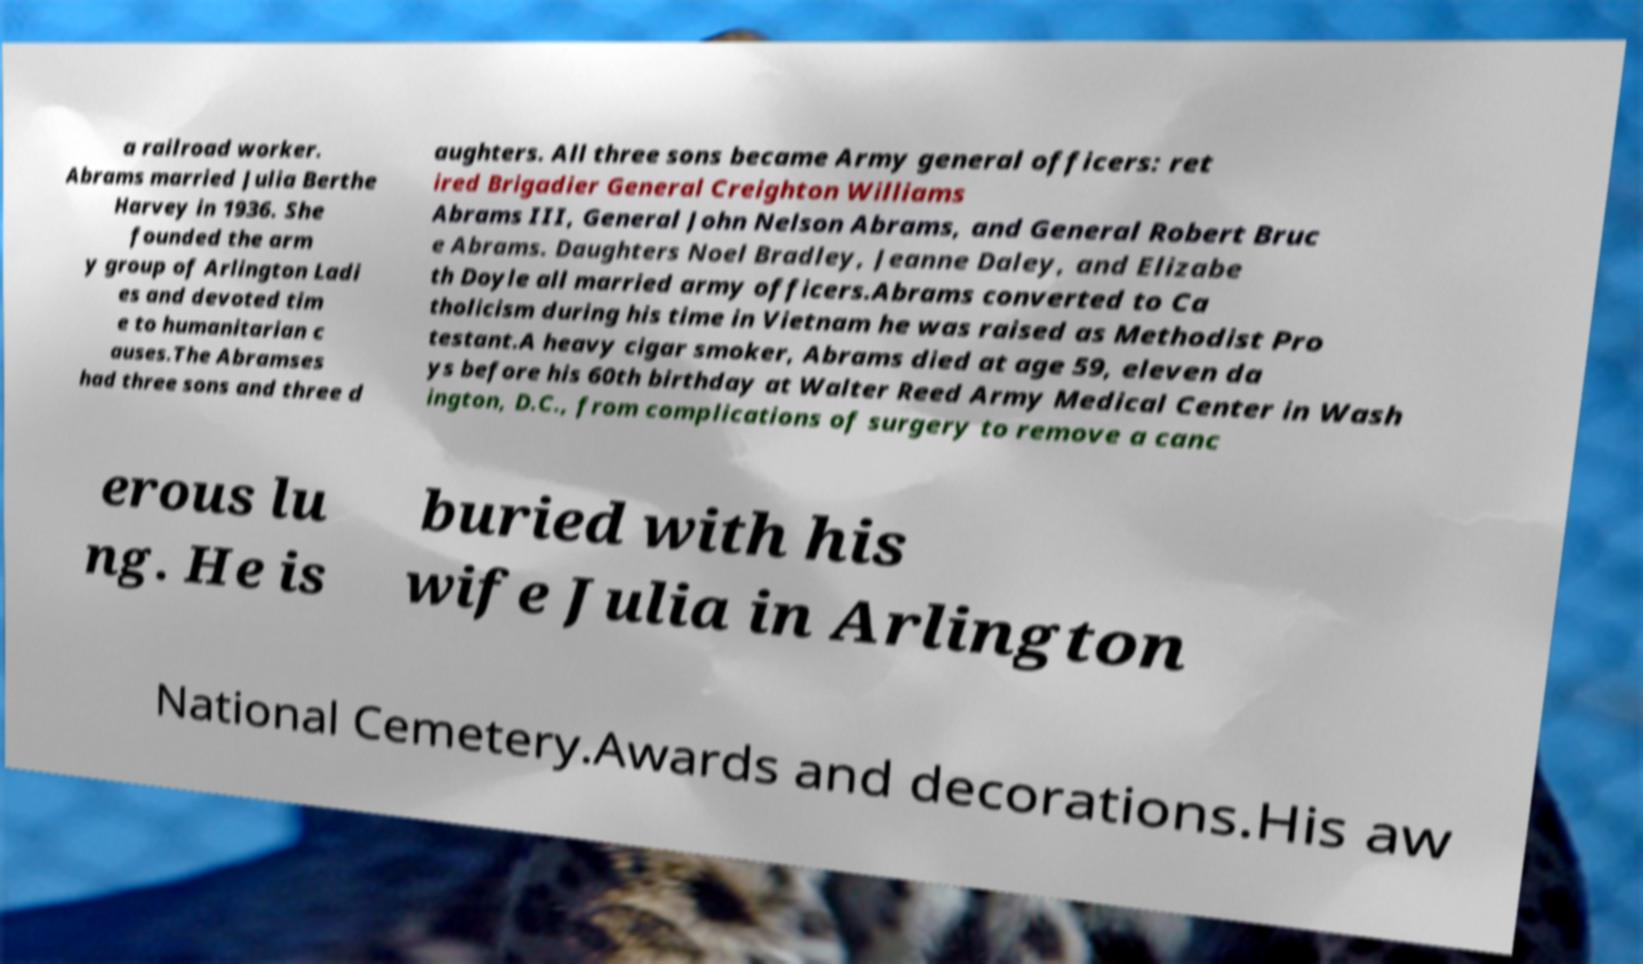For documentation purposes, I need the text within this image transcribed. Could you provide that? a railroad worker. Abrams married Julia Berthe Harvey in 1936. She founded the arm y group of Arlington Ladi es and devoted tim e to humanitarian c auses.The Abramses had three sons and three d aughters. All three sons became Army general officers: ret ired Brigadier General Creighton Williams Abrams III, General John Nelson Abrams, and General Robert Bruc e Abrams. Daughters Noel Bradley, Jeanne Daley, and Elizabe th Doyle all married army officers.Abrams converted to Ca tholicism during his time in Vietnam he was raised as Methodist Pro testant.A heavy cigar smoker, Abrams died at age 59, eleven da ys before his 60th birthday at Walter Reed Army Medical Center in Wash ington, D.C., from complications of surgery to remove a canc erous lu ng. He is buried with his wife Julia in Arlington National Cemetery.Awards and decorations.His aw 